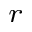Convert formula to latex. <formula><loc_0><loc_0><loc_500><loc_500>_ { r }</formula> 